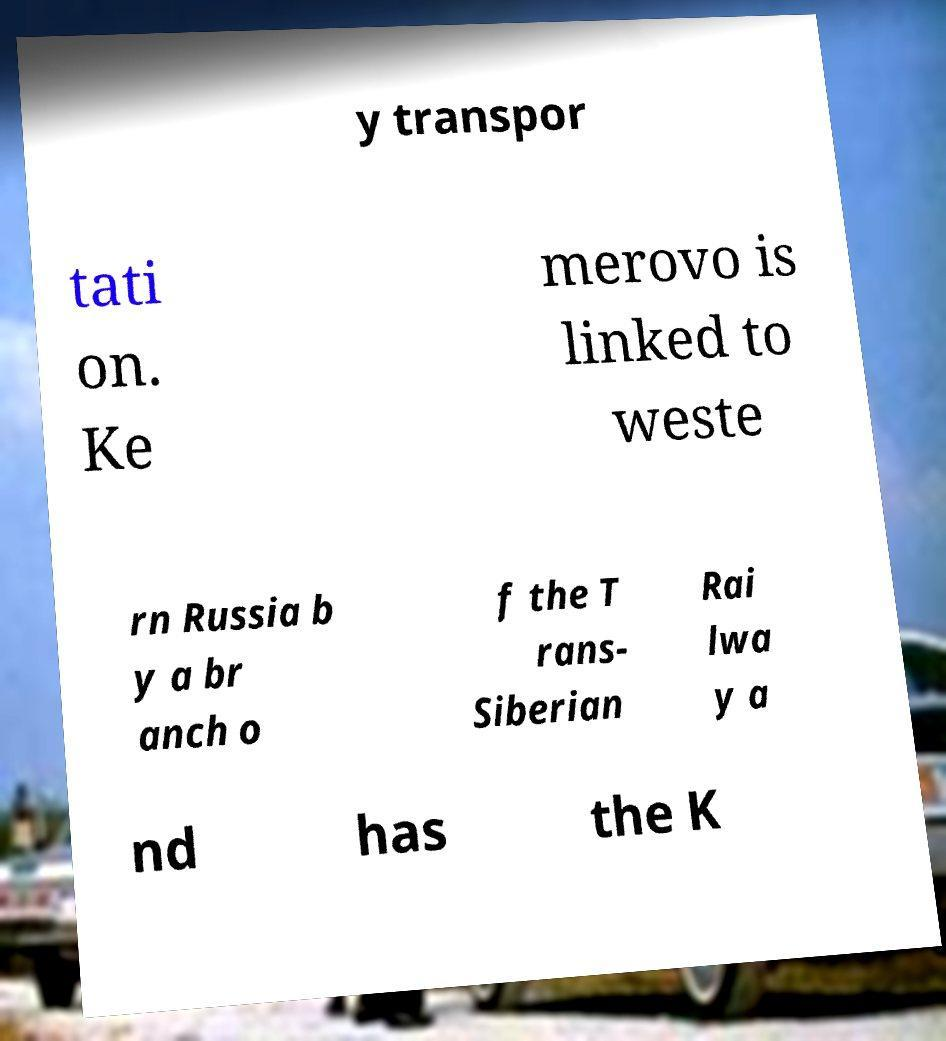Please read and relay the text visible in this image. What does it say? y transpor tati on. Ke merovo is linked to weste rn Russia b y a br anch o f the T rans- Siberian Rai lwa y a nd has the K 